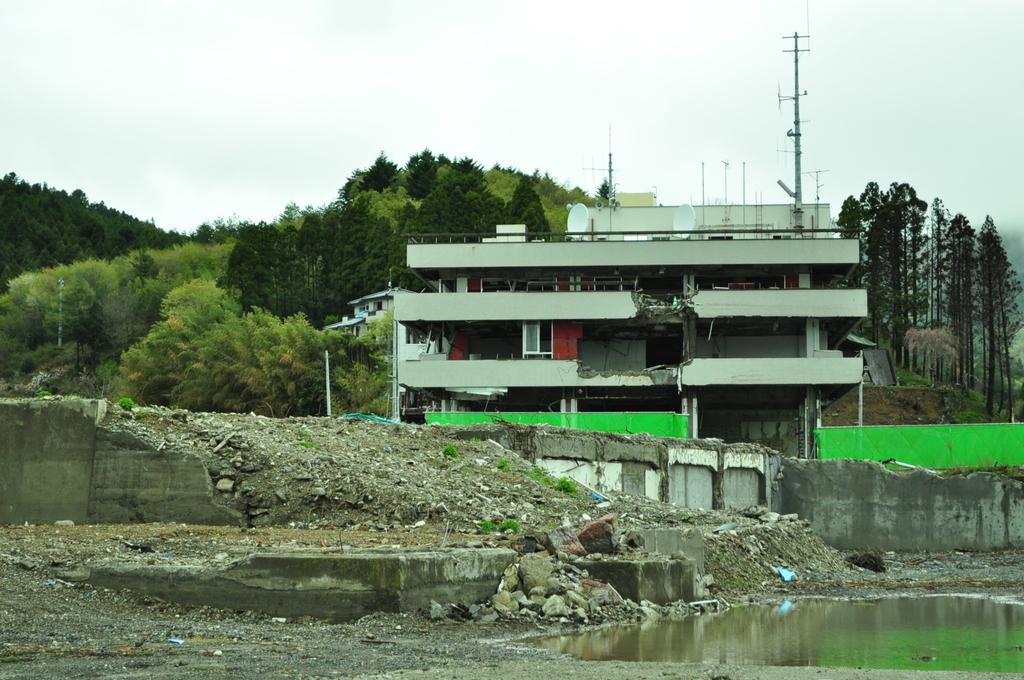What is located in the front of the image? There is water in the front of the image. What can be seen in the center of the image? There are stones in the center of the image. What is visible in the background of the image? There is a building, trees, and poles in the background of the image. What is the condition of the sky in the background of the image? The sky is cloudy in the background of the image. How does the team perform a twist on the beam in the image? There is no team, twist, or beam present in the image. What type of beam is supporting the building in the background of the image? There is no beam supporting the building in the background of the image; it is a complete structure. 